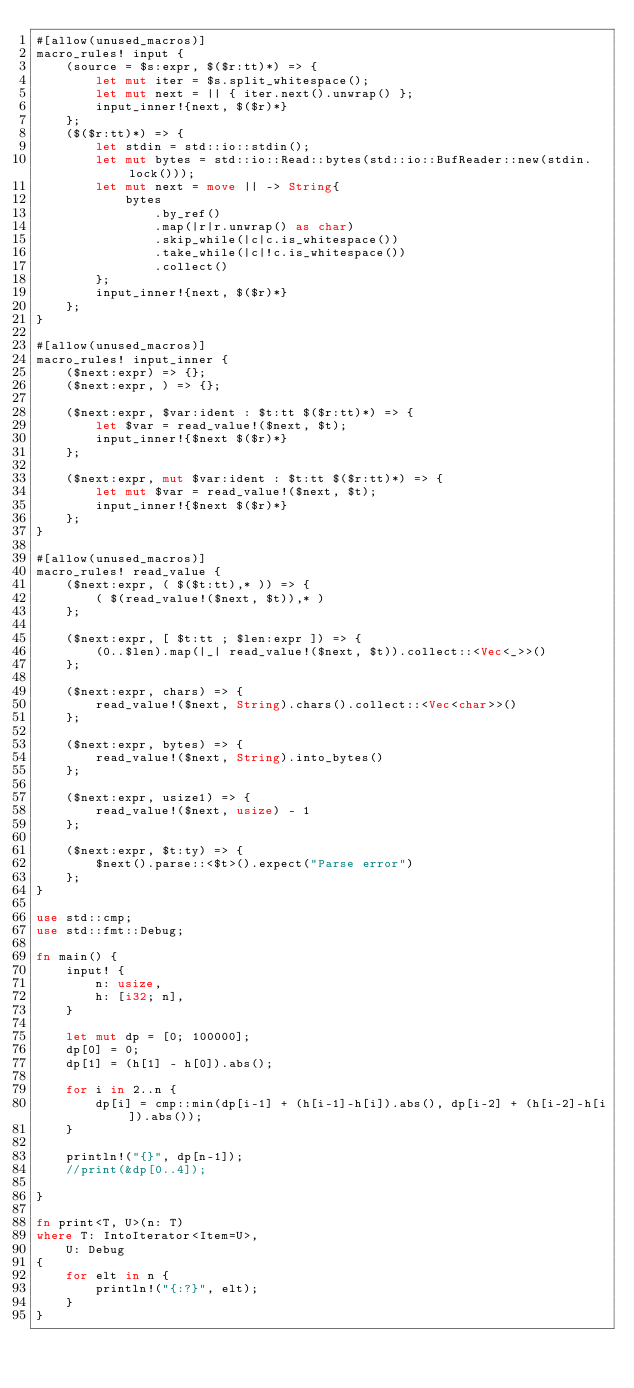Convert code to text. <code><loc_0><loc_0><loc_500><loc_500><_Rust_>#[allow(unused_macros)]
macro_rules! input {
    (source = $s:expr, $($r:tt)*) => {
        let mut iter = $s.split_whitespace();
        let mut next = || { iter.next().unwrap() };
        input_inner!{next, $($r)*}
    };
    ($($r:tt)*) => {
        let stdin = std::io::stdin();
        let mut bytes = std::io::Read::bytes(std::io::BufReader::new(stdin.lock()));
        let mut next = move || -> String{
            bytes
                .by_ref()
                .map(|r|r.unwrap() as char)
                .skip_while(|c|c.is_whitespace())
                .take_while(|c|!c.is_whitespace())
                .collect()
        };
        input_inner!{next, $($r)*}
    };
}
 
#[allow(unused_macros)]
macro_rules! input_inner {
    ($next:expr) => {};
    ($next:expr, ) => {};
 
    ($next:expr, $var:ident : $t:tt $($r:tt)*) => {
        let $var = read_value!($next, $t);
        input_inner!{$next $($r)*}
    };
 
    ($next:expr, mut $var:ident : $t:tt $($r:tt)*) => {
        let mut $var = read_value!($next, $t);
        input_inner!{$next $($r)*}
    };
}
 
#[allow(unused_macros)]
macro_rules! read_value {
    ($next:expr, ( $($t:tt),* )) => {
        ( $(read_value!($next, $t)),* )
    };
 
    ($next:expr, [ $t:tt ; $len:expr ]) => {
        (0..$len).map(|_| read_value!($next, $t)).collect::<Vec<_>>()
    };
 
    ($next:expr, chars) => {
        read_value!($next, String).chars().collect::<Vec<char>>()
    };
 
    ($next:expr, bytes) => {
        read_value!($next, String).into_bytes()
    };
 
    ($next:expr, usize1) => {
        read_value!($next, usize) - 1
    };
 
    ($next:expr, $t:ty) => {
        $next().parse::<$t>().expect("Parse error")
    };
}
 
use std::cmp;
use std::fmt::Debug;

fn main() {
    input! {
        n: usize,
        h: [i32; n],
    }

    let mut dp = [0; 100000];
    dp[0] = 0;
    dp[1] = (h[1] - h[0]).abs();

    for i in 2..n {
        dp[i] = cmp::min(dp[i-1] + (h[i-1]-h[i]).abs(), dp[i-2] + (h[i-2]-h[i]).abs());
    }

    println!("{}", dp[n-1]);
    //print(&dp[0..4]);

}

fn print<T, U>(n: T) 
where T: IntoIterator<Item=U>,
    U: Debug 
{
    for elt in n {
        println!("{:?}", elt);
    }
}</code> 